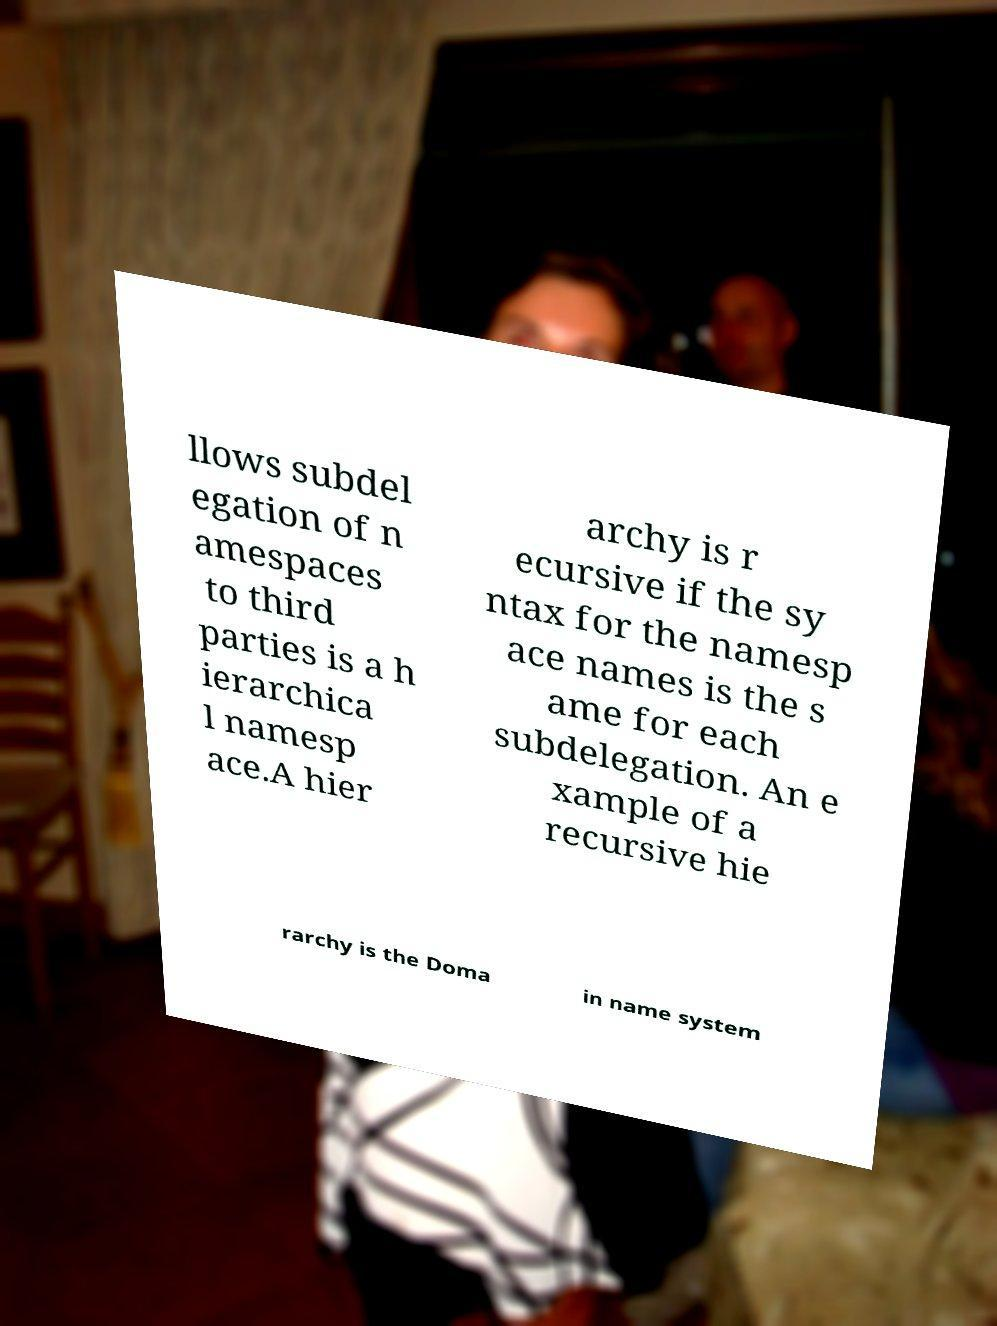For documentation purposes, I need the text within this image transcribed. Could you provide that? llows subdel egation of n amespaces to third parties is a h ierarchica l namesp ace.A hier archy is r ecursive if the sy ntax for the namesp ace names is the s ame for each subdelegation. An e xample of a recursive hie rarchy is the Doma in name system 